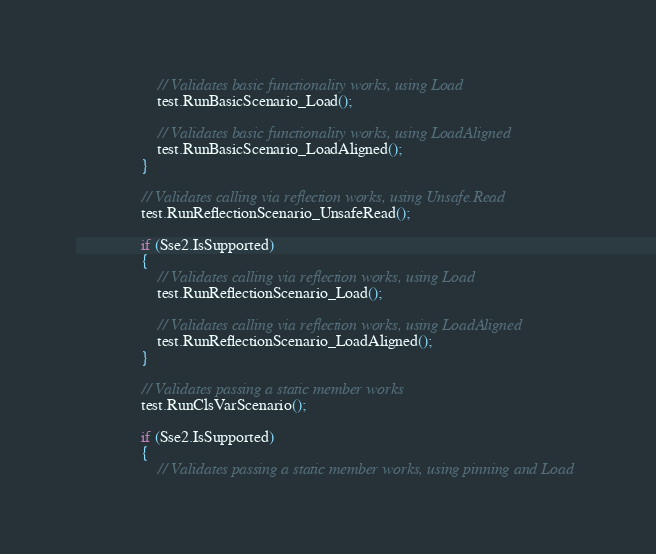Convert code to text. <code><loc_0><loc_0><loc_500><loc_500><_C#_>                    // Validates basic functionality works, using Load
                    test.RunBasicScenario_Load();

                    // Validates basic functionality works, using LoadAligned
                    test.RunBasicScenario_LoadAligned();
                }

                // Validates calling via reflection works, using Unsafe.Read
                test.RunReflectionScenario_UnsafeRead();

                if (Sse2.IsSupported)
                {
                    // Validates calling via reflection works, using Load
                    test.RunReflectionScenario_Load();

                    // Validates calling via reflection works, using LoadAligned
                    test.RunReflectionScenario_LoadAligned();
                }

                // Validates passing a static member works
                test.RunClsVarScenario();

                if (Sse2.IsSupported)
                {
                    // Validates passing a static member works, using pinning and Load</code> 